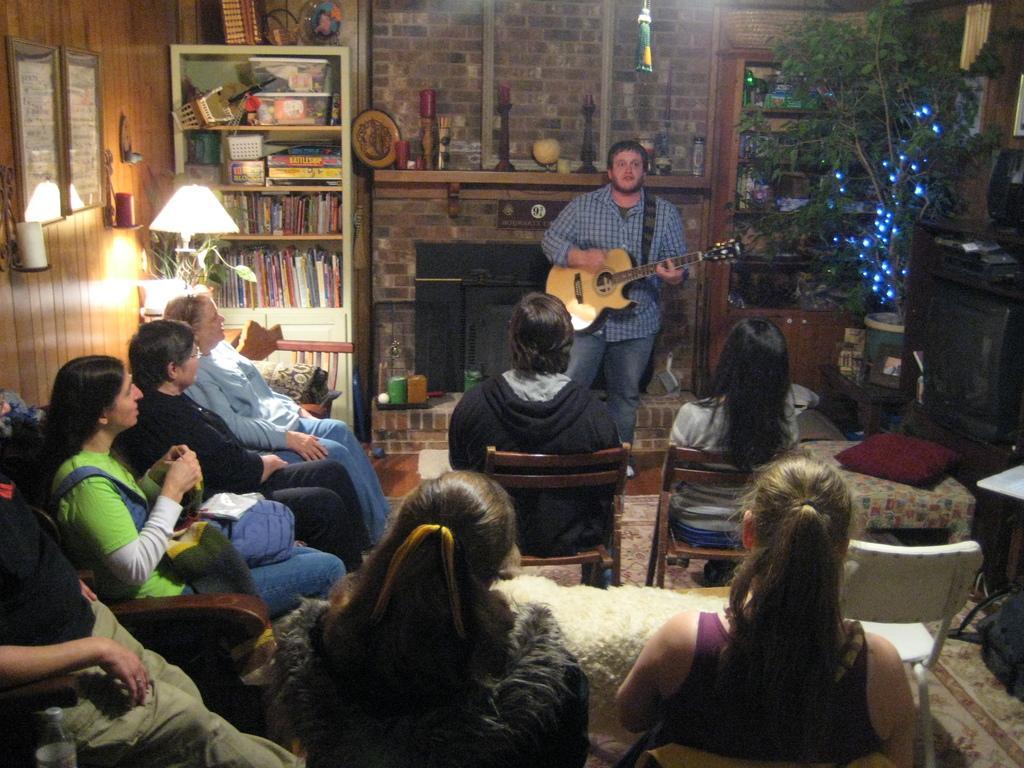Describe this image in one or two sentences. As we can see in the image there are photo frames, shelves, books and few people sitting on chairs and the man who is standing here is holding guitar. ON the right side there is a plant. 